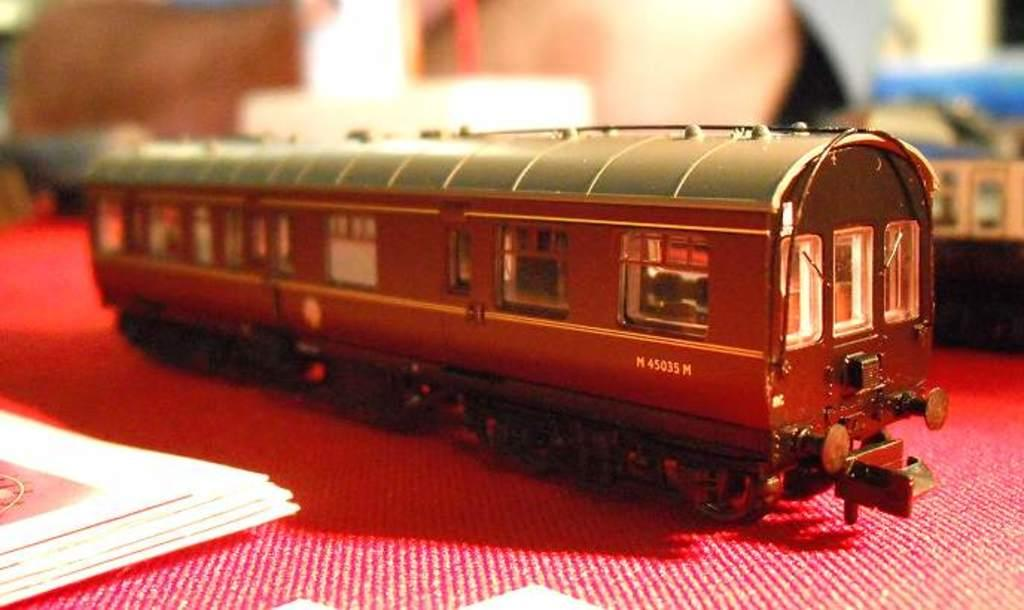What type of toy is present in the image? There is a toy railway coach in the image. What is placed on the object in the image? Papers are placed on an object in the image. Can you describe the background of the image? The background of the image is blurred. What rhythm is the branch in the image following? There is no branch present in the image, so it cannot be following any rhythm. 